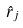<formula> <loc_0><loc_0><loc_500><loc_500>\hat { r } _ { j }</formula> 